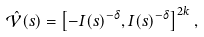<formula> <loc_0><loc_0><loc_500><loc_500>\hat { \mathcal { V } } ( s ) = \left [ - I ( s ) ^ { - \delta } , I ( s ) ^ { - \delta } \right ] ^ { 2 k } ,</formula> 